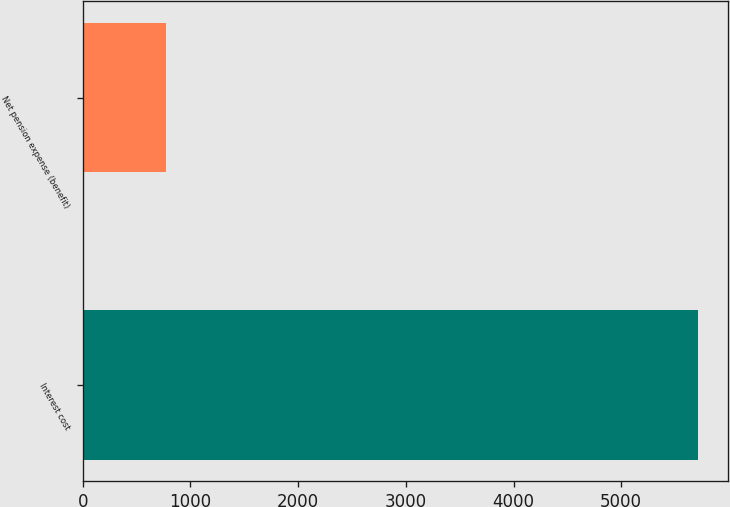Convert chart. <chart><loc_0><loc_0><loc_500><loc_500><bar_chart><fcel>Interest cost<fcel>Net pension expense (benefit)<nl><fcel>5710<fcel>777<nl></chart> 